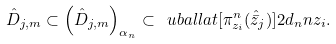<formula> <loc_0><loc_0><loc_500><loc_500>\hat { D } _ { j , m } \subset \left ( \hat { D } _ { j , m } \right ) _ { \alpha _ { n } } \subset \ u b a l l a t [ \pi ^ { n } _ { z _ { i } } ( \hat { \bar { z } } _ { j } ) ] { 2 d _ { n } } { n } { z _ { i } } .</formula> 